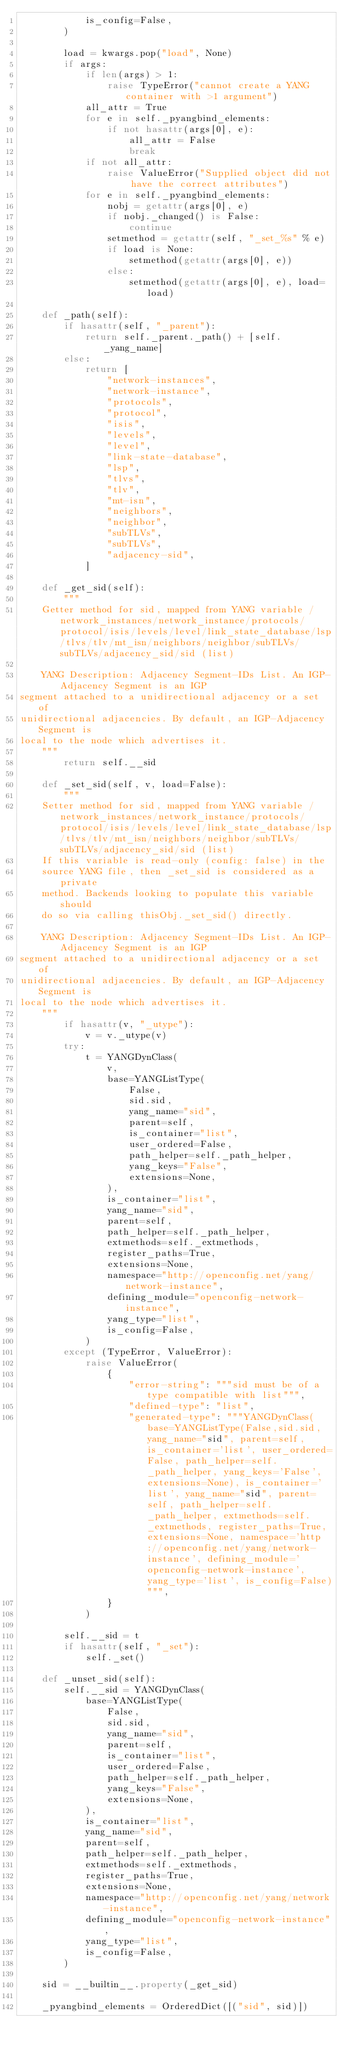Convert code to text. <code><loc_0><loc_0><loc_500><loc_500><_Python_>            is_config=False,
        )

        load = kwargs.pop("load", None)
        if args:
            if len(args) > 1:
                raise TypeError("cannot create a YANG container with >1 argument")
            all_attr = True
            for e in self._pyangbind_elements:
                if not hasattr(args[0], e):
                    all_attr = False
                    break
            if not all_attr:
                raise ValueError("Supplied object did not have the correct attributes")
            for e in self._pyangbind_elements:
                nobj = getattr(args[0], e)
                if nobj._changed() is False:
                    continue
                setmethod = getattr(self, "_set_%s" % e)
                if load is None:
                    setmethod(getattr(args[0], e))
                else:
                    setmethod(getattr(args[0], e), load=load)

    def _path(self):
        if hasattr(self, "_parent"):
            return self._parent._path() + [self._yang_name]
        else:
            return [
                "network-instances",
                "network-instance",
                "protocols",
                "protocol",
                "isis",
                "levels",
                "level",
                "link-state-database",
                "lsp",
                "tlvs",
                "tlv",
                "mt-isn",
                "neighbors",
                "neighbor",
                "subTLVs",
                "subTLVs",
                "adjacency-sid",
            ]

    def _get_sid(self):
        """
    Getter method for sid, mapped from YANG variable /network_instances/network_instance/protocols/protocol/isis/levels/level/link_state_database/lsp/tlvs/tlv/mt_isn/neighbors/neighbor/subTLVs/subTLVs/adjacency_sid/sid (list)

    YANG Description: Adjacency Segment-IDs List. An IGP-Adjacency Segment is an IGP
segment attached to a unidirectional adjacency or a set of
unidirectional adjacencies. By default, an IGP-Adjacency Segment is
local to the node which advertises it.
    """
        return self.__sid

    def _set_sid(self, v, load=False):
        """
    Setter method for sid, mapped from YANG variable /network_instances/network_instance/protocols/protocol/isis/levels/level/link_state_database/lsp/tlvs/tlv/mt_isn/neighbors/neighbor/subTLVs/subTLVs/adjacency_sid/sid (list)
    If this variable is read-only (config: false) in the
    source YANG file, then _set_sid is considered as a private
    method. Backends looking to populate this variable should
    do so via calling thisObj._set_sid() directly.

    YANG Description: Adjacency Segment-IDs List. An IGP-Adjacency Segment is an IGP
segment attached to a unidirectional adjacency or a set of
unidirectional adjacencies. By default, an IGP-Adjacency Segment is
local to the node which advertises it.
    """
        if hasattr(v, "_utype"):
            v = v._utype(v)
        try:
            t = YANGDynClass(
                v,
                base=YANGListType(
                    False,
                    sid.sid,
                    yang_name="sid",
                    parent=self,
                    is_container="list",
                    user_ordered=False,
                    path_helper=self._path_helper,
                    yang_keys="False",
                    extensions=None,
                ),
                is_container="list",
                yang_name="sid",
                parent=self,
                path_helper=self._path_helper,
                extmethods=self._extmethods,
                register_paths=True,
                extensions=None,
                namespace="http://openconfig.net/yang/network-instance",
                defining_module="openconfig-network-instance",
                yang_type="list",
                is_config=False,
            )
        except (TypeError, ValueError):
            raise ValueError(
                {
                    "error-string": """sid must be of a type compatible with list""",
                    "defined-type": "list",
                    "generated-type": """YANGDynClass(base=YANGListType(False,sid.sid, yang_name="sid", parent=self, is_container='list', user_ordered=False, path_helper=self._path_helper, yang_keys='False', extensions=None), is_container='list', yang_name="sid", parent=self, path_helper=self._path_helper, extmethods=self._extmethods, register_paths=True, extensions=None, namespace='http://openconfig.net/yang/network-instance', defining_module='openconfig-network-instance', yang_type='list', is_config=False)""",
                }
            )

        self.__sid = t
        if hasattr(self, "_set"):
            self._set()

    def _unset_sid(self):
        self.__sid = YANGDynClass(
            base=YANGListType(
                False,
                sid.sid,
                yang_name="sid",
                parent=self,
                is_container="list",
                user_ordered=False,
                path_helper=self._path_helper,
                yang_keys="False",
                extensions=None,
            ),
            is_container="list",
            yang_name="sid",
            parent=self,
            path_helper=self._path_helper,
            extmethods=self._extmethods,
            register_paths=True,
            extensions=None,
            namespace="http://openconfig.net/yang/network-instance",
            defining_module="openconfig-network-instance",
            yang_type="list",
            is_config=False,
        )

    sid = __builtin__.property(_get_sid)

    _pyangbind_elements = OrderedDict([("sid", sid)])
</code> 